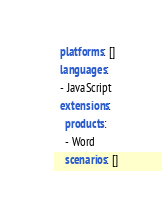Convert code to text. <code><loc_0><loc_0><loc_500><loc_500><_YAML_>  platforms: []
  languages:
  - JavaScript
  extensions:
    products:
    - Word
    scenarios: []
</code> 